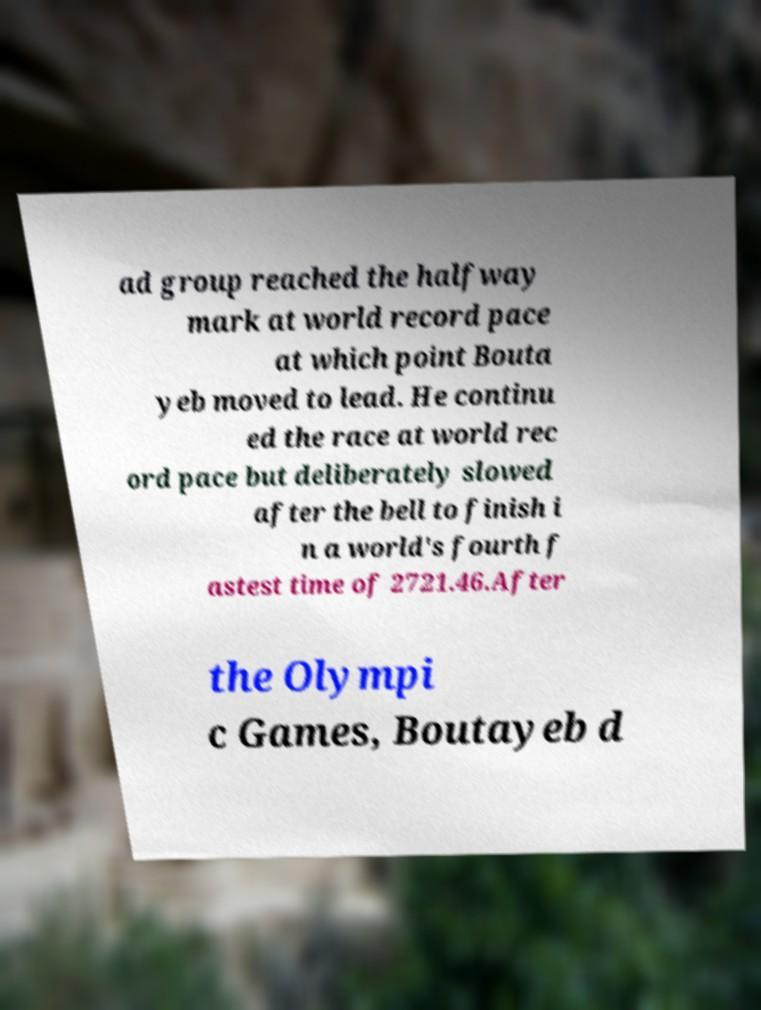I need the written content from this picture converted into text. Can you do that? ad group reached the halfway mark at world record pace at which point Bouta yeb moved to lead. He continu ed the race at world rec ord pace but deliberately slowed after the bell to finish i n a world's fourth f astest time of 2721.46.After the Olympi c Games, Boutayeb d 